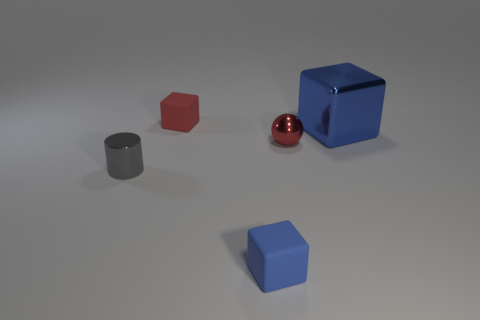Add 4 blue rubber things. How many objects exist? 9 Subtract all cylinders. How many objects are left? 4 Subtract all tiny red metallic balls. Subtract all red blocks. How many objects are left? 3 Add 4 small balls. How many small balls are left? 5 Add 5 red metallic things. How many red metallic things exist? 6 Subtract 0 blue spheres. How many objects are left? 5 